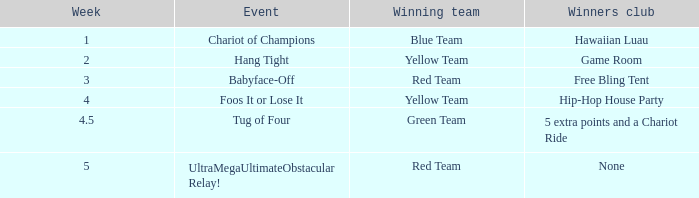Could you parse the entire table? {'header': ['Week', 'Event', 'Winning team', 'Winners club'], 'rows': [['1', 'Chariot of Champions', 'Blue Team', 'Hawaiian Luau'], ['2', 'Hang Tight', 'Yellow Team', 'Game Room'], ['3', 'Babyface-Off', 'Red Team', 'Free Bling Tent'], ['4', 'Foos It or Lose It', 'Yellow Team', 'Hip-Hop House Party'], ['4.5', 'Tug of Four', 'Green Team', '5 extra points and a Chariot Ride'], ['5', 'UltraMegaUltimateObstacular Relay!', 'Red Team', 'None']]} Which Week has an Air Date of august 2, 2008? 2.0. 